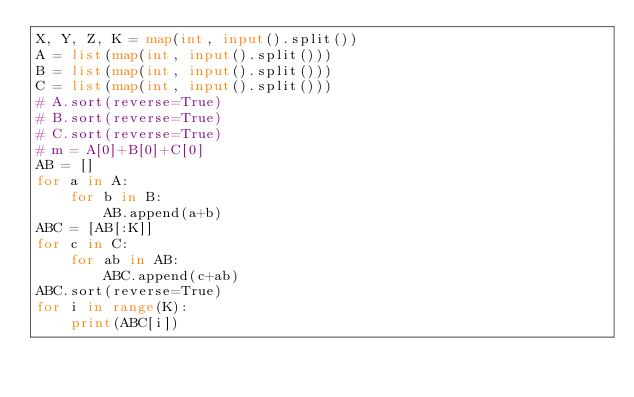<code> <loc_0><loc_0><loc_500><loc_500><_Python_>X, Y, Z, K = map(int, input().split())
A = list(map(int, input().split()))
B = list(map(int, input().split()))
C = list(map(int, input().split()))
# A.sort(reverse=True)
# B.sort(reverse=True)
# C.sort(reverse=True)
# m = A[0]+B[0]+C[0]
AB = []
for a in A:
    for b in B:
        AB.append(a+b)
ABC = [AB[:K]]
for c in C:
    for ab in AB:
        ABC.append(c+ab)
ABC.sort(reverse=True)
for i in range(K):
    print(ABC[i])</code> 